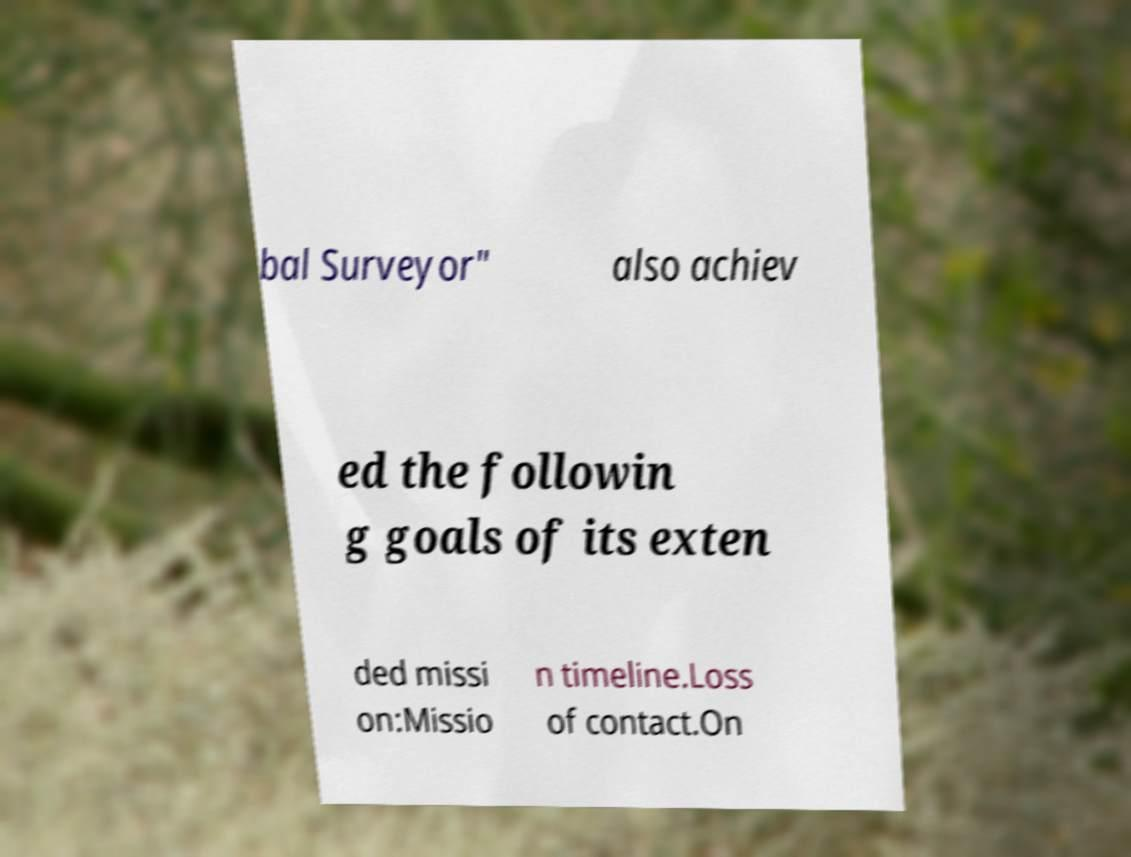Can you read and provide the text displayed in the image?This photo seems to have some interesting text. Can you extract and type it out for me? bal Surveyor" also achiev ed the followin g goals of its exten ded missi on:Missio n timeline.Loss of contact.On 